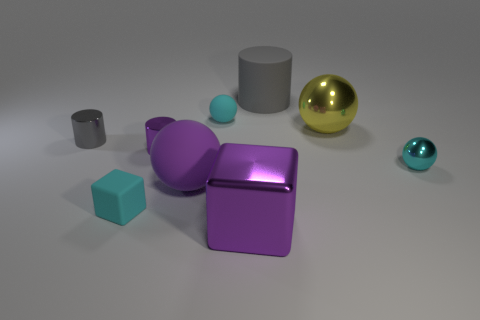What is the size of the cube that is the same color as the big rubber sphere?
Provide a short and direct response. Large. Does the big matte sphere have the same color as the matte block?
Ensure brevity in your answer.  No. Are there more things in front of the gray rubber cylinder than large purple metal things?
Offer a very short reply. Yes. How many small rubber things are right of the block to the left of the small purple thing?
Ensure brevity in your answer.  1. Does the block that is on the left side of the shiny block have the same material as the large purple thing in front of the tiny rubber cube?
Offer a terse response. No. What is the material of the thing that is the same color as the large cylinder?
Give a very brief answer. Metal. What number of cyan metallic objects have the same shape as the tiny gray object?
Provide a succinct answer. 0. Does the large gray object have the same material as the large sphere in front of the large yellow shiny object?
Your answer should be compact. Yes. What is the material of the purple cylinder that is the same size as the cyan rubber ball?
Ensure brevity in your answer.  Metal. Is there a cyan metal thing of the same size as the cyan shiny ball?
Provide a short and direct response. No. 